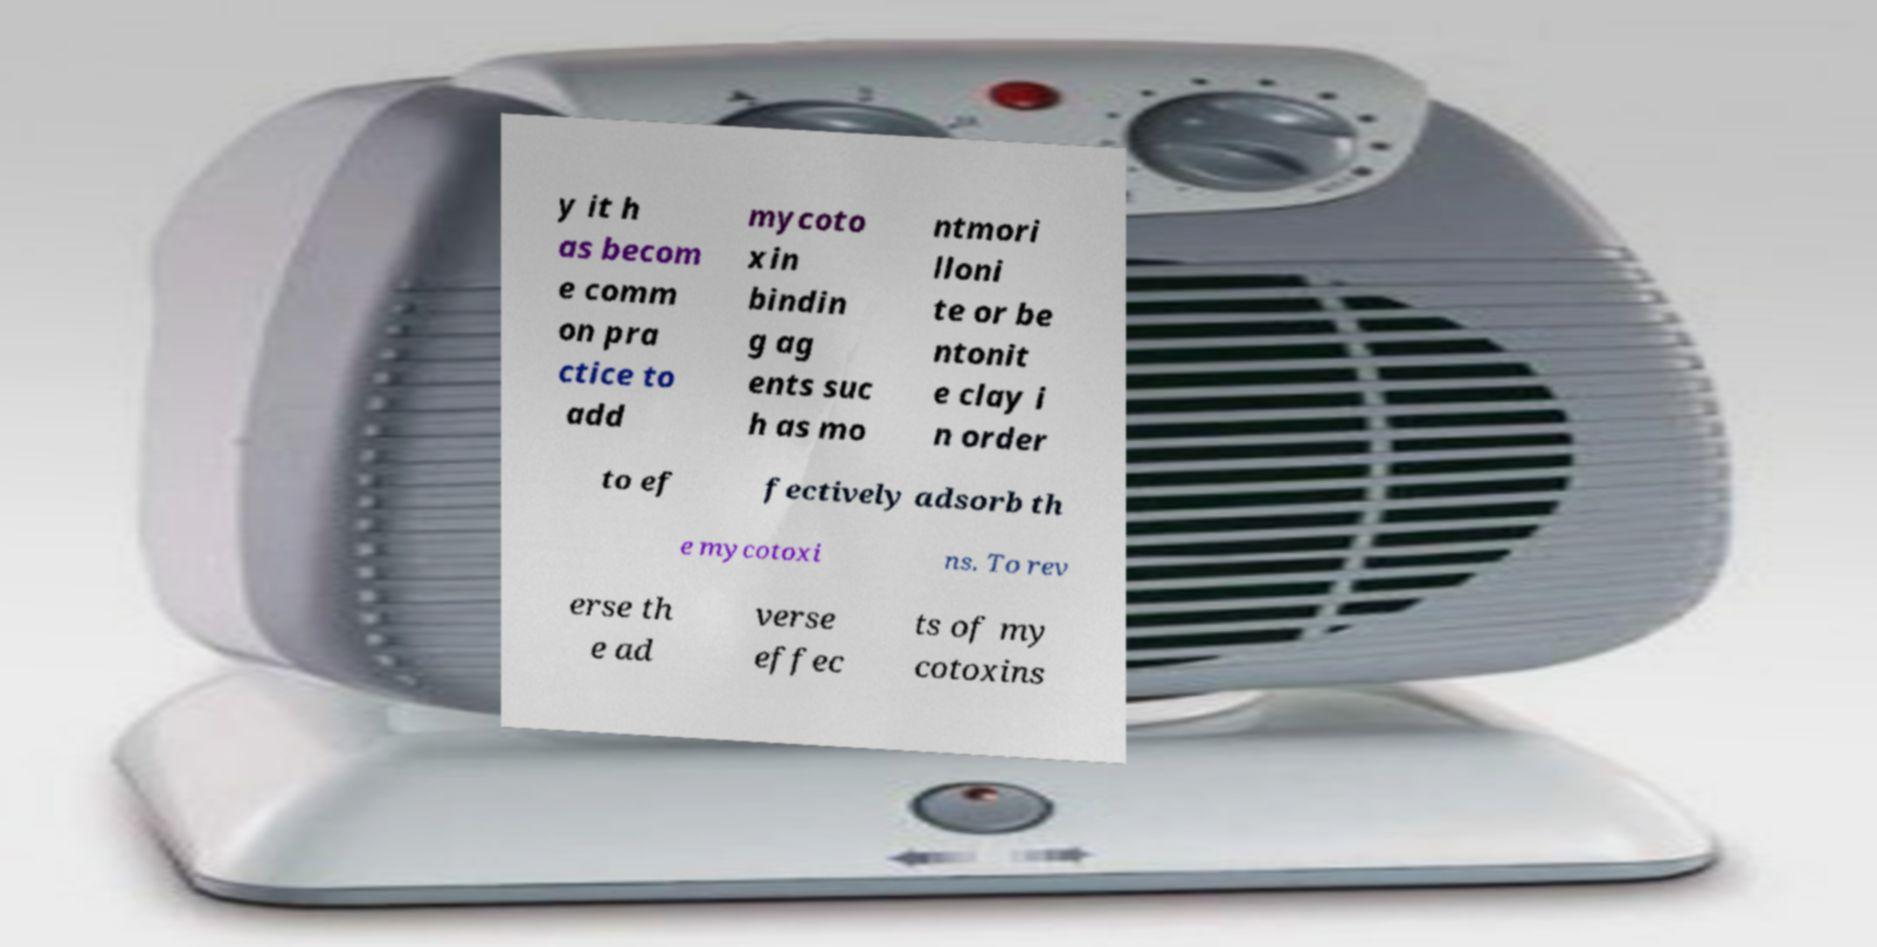Can you accurately transcribe the text from the provided image for me? y it h as becom e comm on pra ctice to add mycoto xin bindin g ag ents suc h as mo ntmori lloni te or be ntonit e clay i n order to ef fectively adsorb th e mycotoxi ns. To rev erse th e ad verse effec ts of my cotoxins 